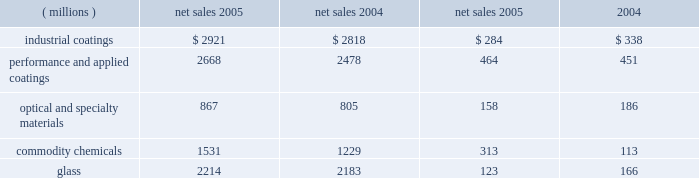Management 2019s discussion and analysis of increased volumes in our performance and applied coatings , optical and specialty materials and glass reportable business segments was offset by volume declines in the commodity chemicals reportable business segment .
The volume decline in the commodity chemicals reportable business segment was due in part to lost sales resulting from the impact of hurricane rita , as discussed below .
Cost of sales as a percentage of sales increased to 63.5% ( 63.5 % ) as compared to 63.1% ( 63.1 % ) in 2004 .
Inflation , including higher coatings raw material costs and higher energy costs in our commodity chemicals and glass reportable business segments increased our cost of sales .
Selling , general and administrative expense declined slightly as a percentage of sales to 17.4% ( 17.4 % ) despite increasing by $ 56 million in 2005 .
These costs increased primarily due to increased advertising in our optical products operating segment and higher expenses due to store expansions in our architectural coatings operating segment .
Interest expense declined $ 9 million in 2005 , reflecting the year over year reduction in the outstanding debt balance of $ 80 million .
Other charges increased $ 284 million in 2005 primarily due to pretax charges of $ 132 million related to the marvin legal settlement , net of $ 18 million in insurance recoveries , $ 61 million for the federal glass class action antitrust legal settlement , $ 34 million of direct costs related to the impact of hurricanes rita and katrina , $ 27 million for an asset impairment charge in our fine chemicals operating segment , $ 19 million for debt refinancing costs and an increase of $ 12 million for environmental remediation costs .
Net income and earnings per share 2013 assuming dilution for 2005 were $ 596 million and $ 3.49 respectively , compared to $ 683 million and $ 3.95 , respectively , for 2004 .
Net income in 2005 included aftertax charges of $ 117 million , or 68 cents a share , for legal settlements net of insurance ; $ 21 million , or 12 cents a share for direct costs related to the impact of hurricanes katrina and rita ; $ 17 million , or 10 cents a share related to an asset impairment charge related to our fine chemicals business ; and $ 12 million , or 7 cents a share , for debt refinancing costs .
The legal settlements net of insurance include aftertax charges of $ 80 million for the marvin legal settlement , net of insurance recoveries , and $ 37 million for the impact of the federal glass class action antitrust legal settlement .
Net income for 2005 and 2004 included an aftertax charge of $ 13 million , or 8 cents a share , and $ 19 million , or 11 cents a share , respectively , to reflect the net increase in the current value of the company 2019s obligation relating to asbestos claims under the ppg settlement arrangement .
Results of reportable business segments net sales segment income ( millions ) 2005 2004 2005 2004 industrial coatings $ 2921 $ 2818 $ 284 $ 338 performance and applied coatings 2668 2478 464 451 optical and specialty materials 867 805 158 186 .
Sales of industrial coatings increased $ 103 million or 4% ( 4 % ) in 2005 .
Sales increased 2% ( 2 % ) due to higher selling prices in our industrial and packaging coatings businesses and 2% ( 2 % ) due to the positive effects of foreign currency translation .
Volume was flat year over year as increased volume in automotive coatings was offset by lower volume in industrial and packaging coatings .
Segment income decreased $ 54 million in 2005 .
The decrease in segment income was due to the adverse impact of inflation , including raw materials costs increases of about $ 170 million , which more than offset the benefits of higher selling prices , improved sales margin mix , formula cost reductions , lower manufacturing costs and higher other income .
Performance and applied coatings sales increased $ 190 million or 8% ( 8 % ) in 2005 .
Sales increased 4% ( 4 % ) due to higher selling prices in all three operating segments , 3% ( 3 % ) due to increased volumes as increases in our aerospace and architectural coatings businesses exceeded volume declines in automotive refinish , and 1% ( 1 % ) due to the positive effects of foreign currency translation .
Performance and applied coatings segment income increased $ 13 million in 2005 .
Segment income increased due to the impact of increased sales volumes described above and higher other income , which combined to offset the negative impacts of higher overhead costs to support the growth in these businesses , particularly in the architectural coatings business , and higher manufacturing costs .
The impact of higher selling prices fully offset the adverse impact of inflation , including raw materials cost increases of about $ 75 million .
Optical and specialty materials sales increased $ 62 million or 8% ( 8 % ) .
Sales increased 8% ( 8 % ) due to higher sales volumes in our optical products and silica businesses , which offset lower sales volumes in our fine chemicals business .
Sales increased 1% ( 1 % ) due to an acquisition in our optical products business and decreased 1% ( 1 % ) due to lower pricing .
Segment income decreased $ 28 million .
The primary factor decreasing segment income was the $ 27 million impairment charge related to our fine chemicals business .
The impact of higher sales volumes described above was offset by higher inflation , including increased energy costs ; lower selling prices ; increased overhead costs in our optical products business to support growth 24 2006 ppg annual report and form 10-k 4282_txt .
What was operating income return for 2005 in the industrial coatings segment? 
Computations: (284 / 2921)
Answer: 0.09723. 